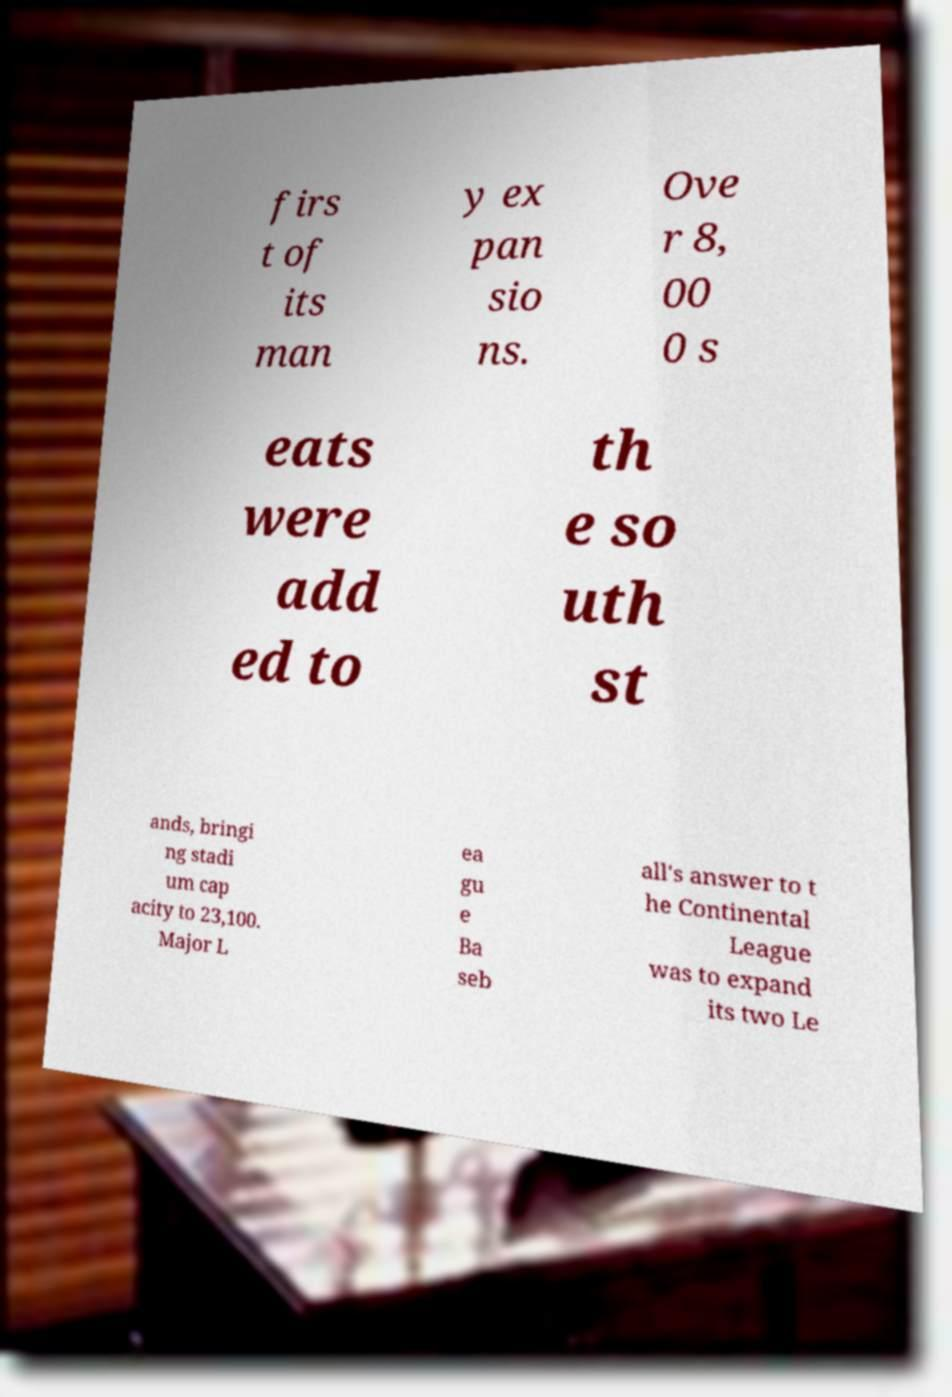Can you accurately transcribe the text from the provided image for me? firs t of its man y ex pan sio ns. Ove r 8, 00 0 s eats were add ed to th e so uth st ands, bringi ng stadi um cap acity to 23,100. Major L ea gu e Ba seb all's answer to t he Continental League was to expand its two Le 